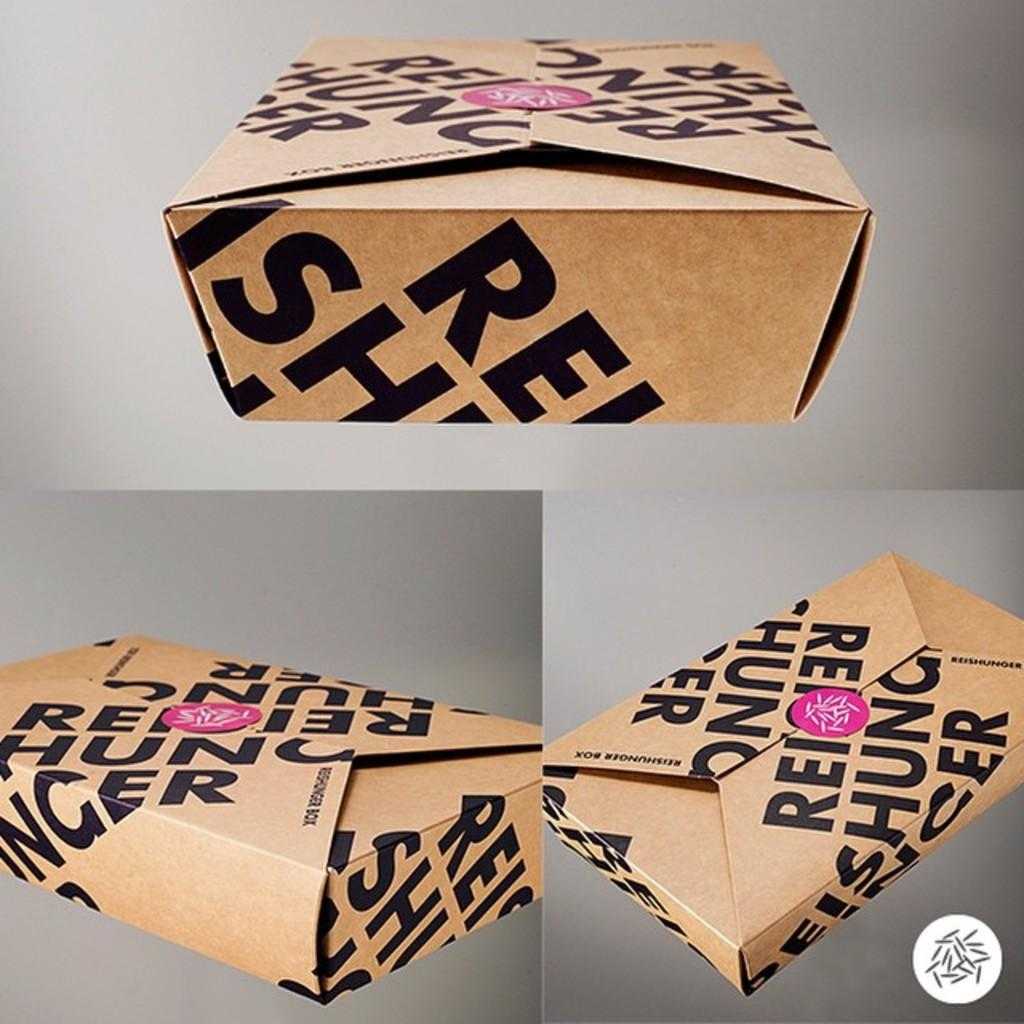<image>
Give a short and clear explanation of the subsequent image. A brown foldable carton has the letters "RE" in front of a pink sticker on the top. 